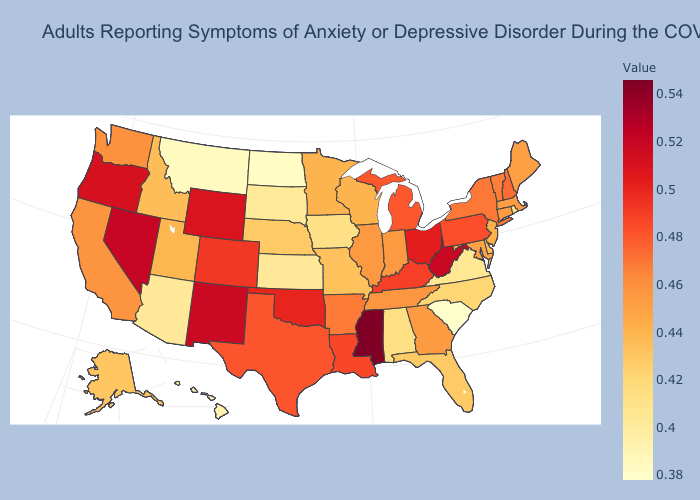Which states hav the highest value in the West?
Be succinct. Nevada. Which states have the lowest value in the USA?
Keep it brief. South Carolina. Among the states that border Mississippi , which have the lowest value?
Be succinct. Alabama. Among the states that border Arizona , which have the highest value?
Answer briefly. Nevada. Which states have the lowest value in the Northeast?
Write a very short answer. Rhode Island. Among the states that border Pennsylvania , does New Jersey have the lowest value?
Write a very short answer. No. Among the states that border Kansas , does Nebraska have the lowest value?
Quick response, please. Yes. Does the map have missing data?
Write a very short answer. No. Which states have the lowest value in the West?
Answer briefly. Montana. 